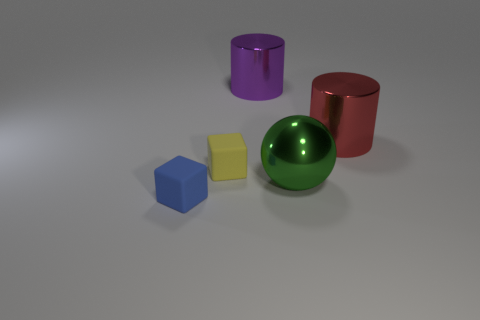Add 3 rubber cubes. How many objects exist? 8 Subtract all cylinders. How many objects are left? 3 Subtract all small rubber objects. Subtract all large shiny things. How many objects are left? 0 Add 5 large metal spheres. How many large metal spheres are left? 6 Add 5 small green cubes. How many small green cubes exist? 5 Subtract 0 brown cylinders. How many objects are left? 5 